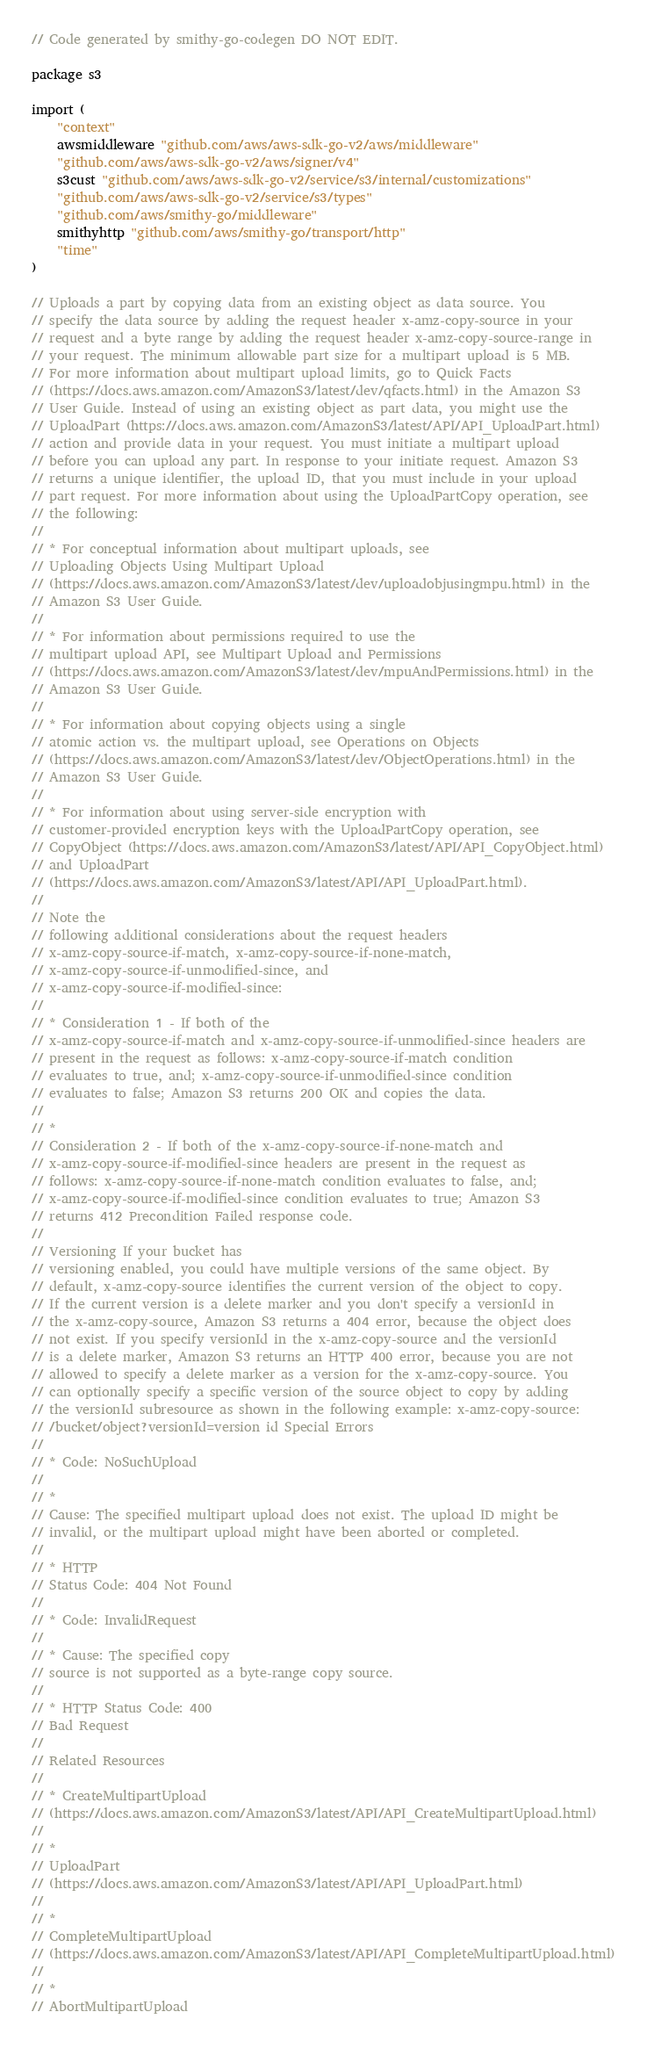Convert code to text. <code><loc_0><loc_0><loc_500><loc_500><_Go_>// Code generated by smithy-go-codegen DO NOT EDIT.

package s3

import (
	"context"
	awsmiddleware "github.com/aws/aws-sdk-go-v2/aws/middleware"
	"github.com/aws/aws-sdk-go-v2/aws/signer/v4"
	s3cust "github.com/aws/aws-sdk-go-v2/service/s3/internal/customizations"
	"github.com/aws/aws-sdk-go-v2/service/s3/types"
	"github.com/aws/smithy-go/middleware"
	smithyhttp "github.com/aws/smithy-go/transport/http"
	"time"
)

// Uploads a part by copying data from an existing object as data source. You
// specify the data source by adding the request header x-amz-copy-source in your
// request and a byte range by adding the request header x-amz-copy-source-range in
// your request. The minimum allowable part size for a multipart upload is 5 MB.
// For more information about multipart upload limits, go to Quick Facts
// (https://docs.aws.amazon.com/AmazonS3/latest/dev/qfacts.html) in the Amazon S3
// User Guide. Instead of using an existing object as part data, you might use the
// UploadPart (https://docs.aws.amazon.com/AmazonS3/latest/API/API_UploadPart.html)
// action and provide data in your request. You must initiate a multipart upload
// before you can upload any part. In response to your initiate request. Amazon S3
// returns a unique identifier, the upload ID, that you must include in your upload
// part request. For more information about using the UploadPartCopy operation, see
// the following:
//
// * For conceptual information about multipart uploads, see
// Uploading Objects Using Multipart Upload
// (https://docs.aws.amazon.com/AmazonS3/latest/dev/uploadobjusingmpu.html) in the
// Amazon S3 User Guide.
//
// * For information about permissions required to use the
// multipart upload API, see Multipart Upload and Permissions
// (https://docs.aws.amazon.com/AmazonS3/latest/dev/mpuAndPermissions.html) in the
// Amazon S3 User Guide.
//
// * For information about copying objects using a single
// atomic action vs. the multipart upload, see Operations on Objects
// (https://docs.aws.amazon.com/AmazonS3/latest/dev/ObjectOperations.html) in the
// Amazon S3 User Guide.
//
// * For information about using server-side encryption with
// customer-provided encryption keys with the UploadPartCopy operation, see
// CopyObject (https://docs.aws.amazon.com/AmazonS3/latest/API/API_CopyObject.html)
// and UploadPart
// (https://docs.aws.amazon.com/AmazonS3/latest/API/API_UploadPart.html).
//
// Note the
// following additional considerations about the request headers
// x-amz-copy-source-if-match, x-amz-copy-source-if-none-match,
// x-amz-copy-source-if-unmodified-since, and
// x-amz-copy-source-if-modified-since:
//
// * Consideration 1 - If both of the
// x-amz-copy-source-if-match and x-amz-copy-source-if-unmodified-since headers are
// present in the request as follows: x-amz-copy-source-if-match condition
// evaluates to true, and; x-amz-copy-source-if-unmodified-since condition
// evaluates to false; Amazon S3 returns 200 OK and copies the data.
//
// *
// Consideration 2 - If both of the x-amz-copy-source-if-none-match and
// x-amz-copy-source-if-modified-since headers are present in the request as
// follows: x-amz-copy-source-if-none-match condition evaluates to false, and;
// x-amz-copy-source-if-modified-since condition evaluates to true; Amazon S3
// returns 412 Precondition Failed response code.
//
// Versioning If your bucket has
// versioning enabled, you could have multiple versions of the same object. By
// default, x-amz-copy-source identifies the current version of the object to copy.
// If the current version is a delete marker and you don't specify a versionId in
// the x-amz-copy-source, Amazon S3 returns a 404 error, because the object does
// not exist. If you specify versionId in the x-amz-copy-source and the versionId
// is a delete marker, Amazon S3 returns an HTTP 400 error, because you are not
// allowed to specify a delete marker as a version for the x-amz-copy-source. You
// can optionally specify a specific version of the source object to copy by adding
// the versionId subresource as shown in the following example: x-amz-copy-source:
// /bucket/object?versionId=version id Special Errors
//
// * Code: NoSuchUpload
//
// *
// Cause: The specified multipart upload does not exist. The upload ID might be
// invalid, or the multipart upload might have been aborted or completed.
//
// * HTTP
// Status Code: 404 Not Found
//
// * Code: InvalidRequest
//
// * Cause: The specified copy
// source is not supported as a byte-range copy source.
//
// * HTTP Status Code: 400
// Bad Request
//
// Related Resources
//
// * CreateMultipartUpload
// (https://docs.aws.amazon.com/AmazonS3/latest/API/API_CreateMultipartUpload.html)
//
// *
// UploadPart
// (https://docs.aws.amazon.com/AmazonS3/latest/API/API_UploadPart.html)
//
// *
// CompleteMultipartUpload
// (https://docs.aws.amazon.com/AmazonS3/latest/API/API_CompleteMultipartUpload.html)
//
// *
// AbortMultipartUpload</code> 